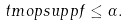<formula> <loc_0><loc_0><loc_500><loc_500>\ t m o p { s u p p } f \leq \alpha .</formula> 